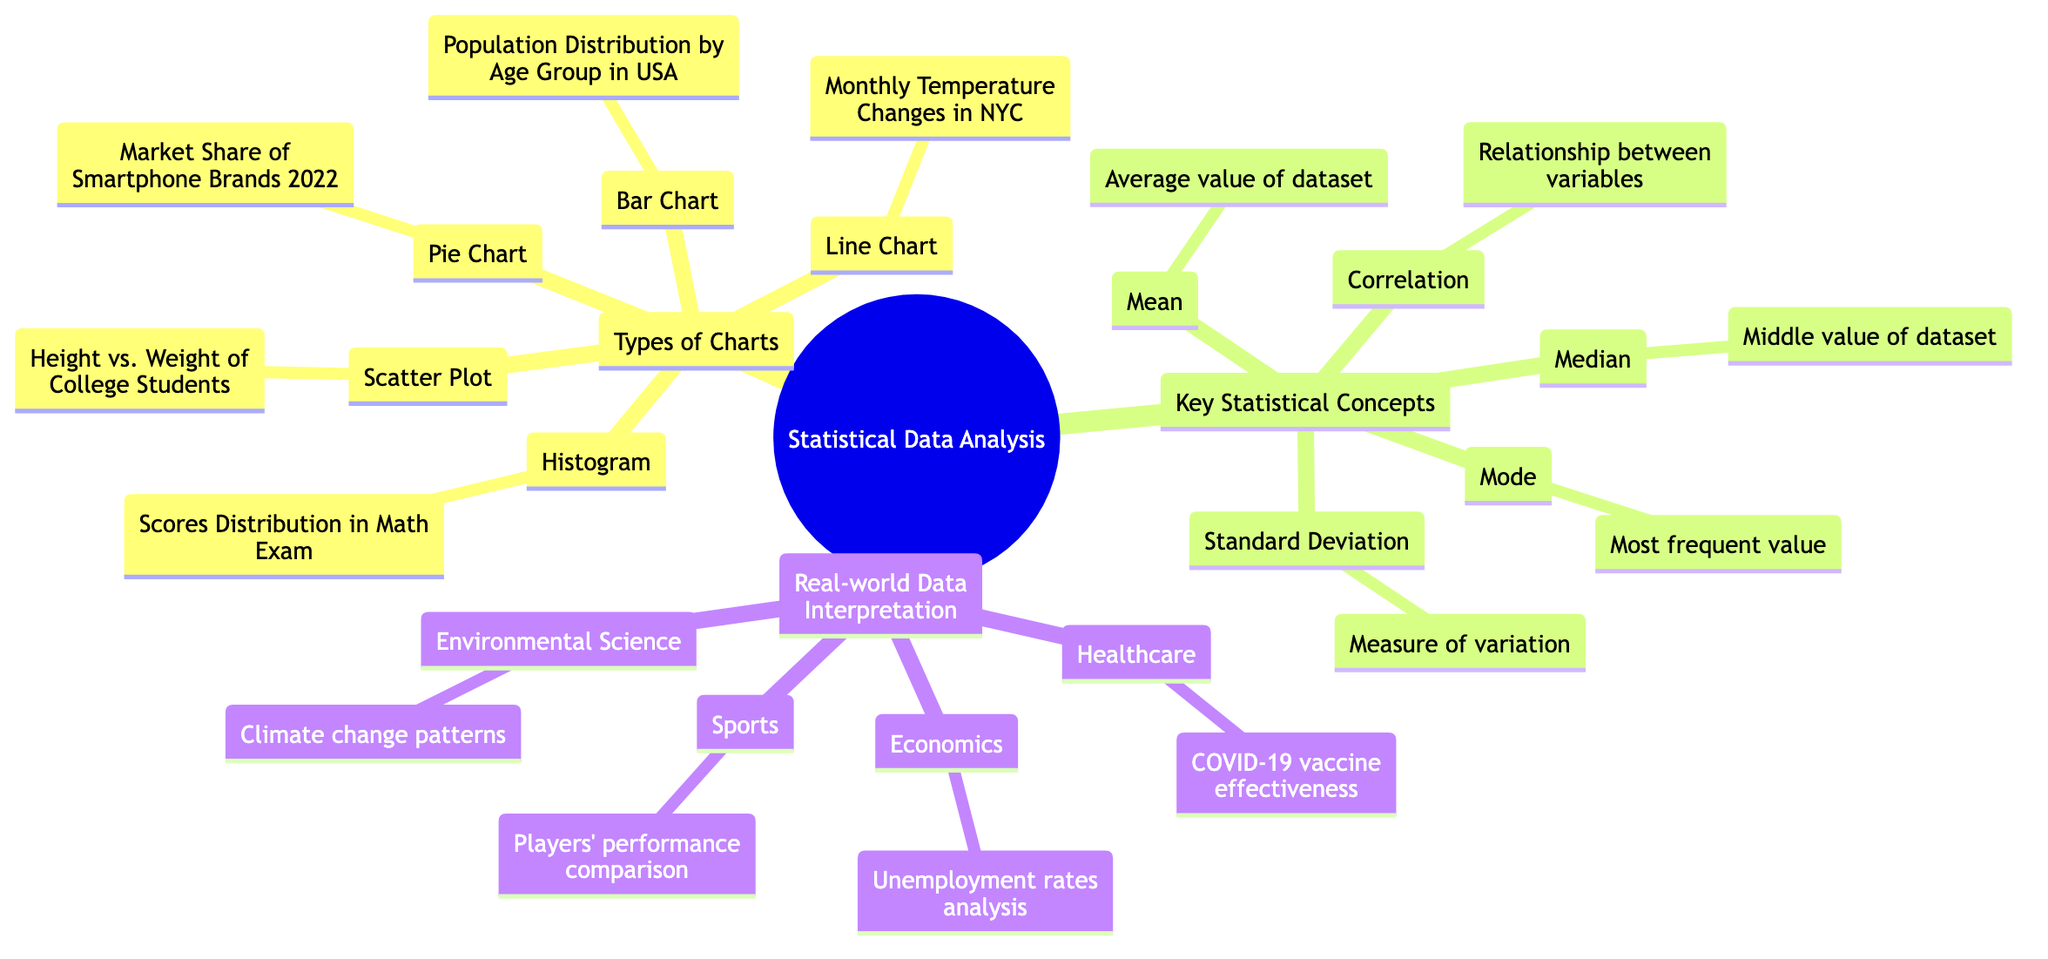What is the type of chart used to represent Market Share of Smartphone Brands? The diagram indicates that the Market Share of Smartphone Brands is represented by a Pie Chart. This can be found under the "Types of Charts" section specifically listed as part of the diagram.
Answer: Pie Chart How many different types of charts are shown in the diagram? The diagram presents five distinct types of charts: Bar Chart, Line Chart, Pie Chart, Scatter Plot, and Histogram. By counting each type listed under "Types of Charts," we arrive at the total.
Answer: Five What statistical measure represents the most frequent value? The diagram specifies that the Mode is the statistical measure that represents the most frequent value within a dataset. This is a direct definition included in the "Key Statistical Concepts" section of the diagram.
Answer: Mode Which chart would you use to analyze Players' performance comparison? According to the diagram, a Scatter Plot is designated for analyzing Players' performance comparison. This information can be found under the "Real-world Data Interpretation" section of the diagram.
Answer: Scatter Plot What statistical concept measures variation? The diagram indicates that the concept of Standard Deviation measures variation. This definition is provided in the "Key Statistical Concepts" section, where each concept is briefly described.
Answer: Standard Deviation What relationship does Correlation describe? The diagram states that Correlation describes the relationship between variables. To answer this, we refer to the description provided in the "Key Statistical Concepts" section that directly defines the term.
Answer: Relationship between variables Which type of chart is used to illustrate COVID-19 vaccine effectiveness? The diagram does not specify a chart type for COVID-19 vaccine effectiveness, but it implies interpretations rather than direct representation. Thus, there isn't a specific chart type listed for it. This requires critical thinking about the broader context of the diagram.
Answer: Not specified What does the median represent in statistics? The diagram notes that the Median represents the middle value of a dataset. This definition is clearly stated in the "Key Statistical Concepts" section, where all the key concepts are briefly described.
Answer: Middle value of dataset How are Monthly Temperature Changes in NYC represented? The diagram indicates that Monthly Temperature Changes in NYC are represented by a Line Chart. This information is straightforwardly listed under the "Types of Charts" section.
Answer: Line Chart 